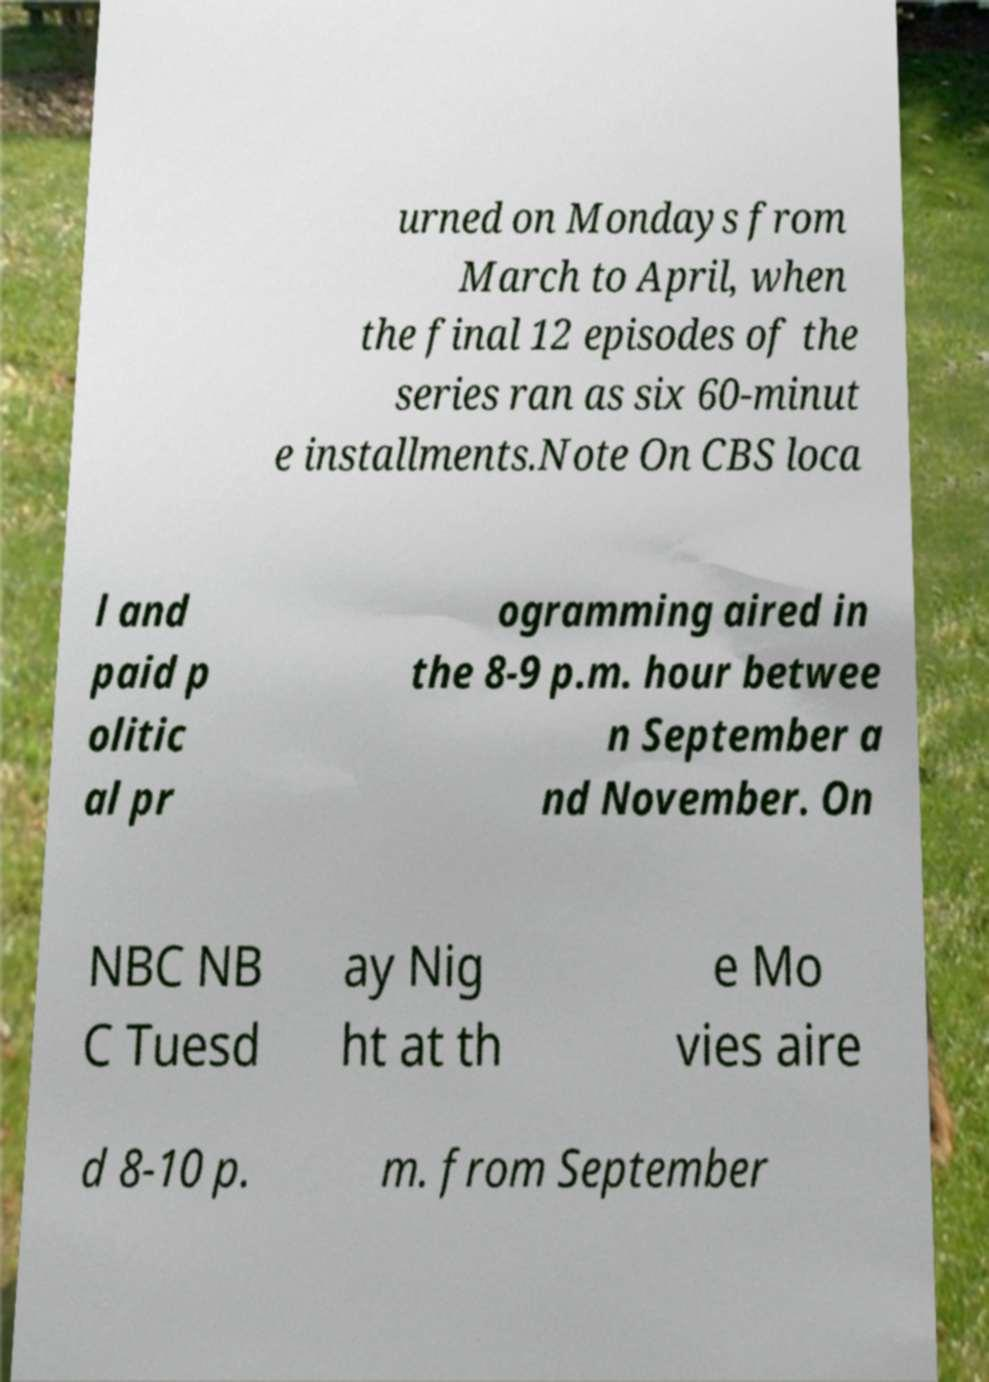Please read and relay the text visible in this image. What does it say? urned on Mondays from March to April, when the final 12 episodes of the series ran as six 60-minut e installments.Note On CBS loca l and paid p olitic al pr ogramming aired in the 8-9 p.m. hour betwee n September a nd November. On NBC NB C Tuesd ay Nig ht at th e Mo vies aire d 8-10 p. m. from September 